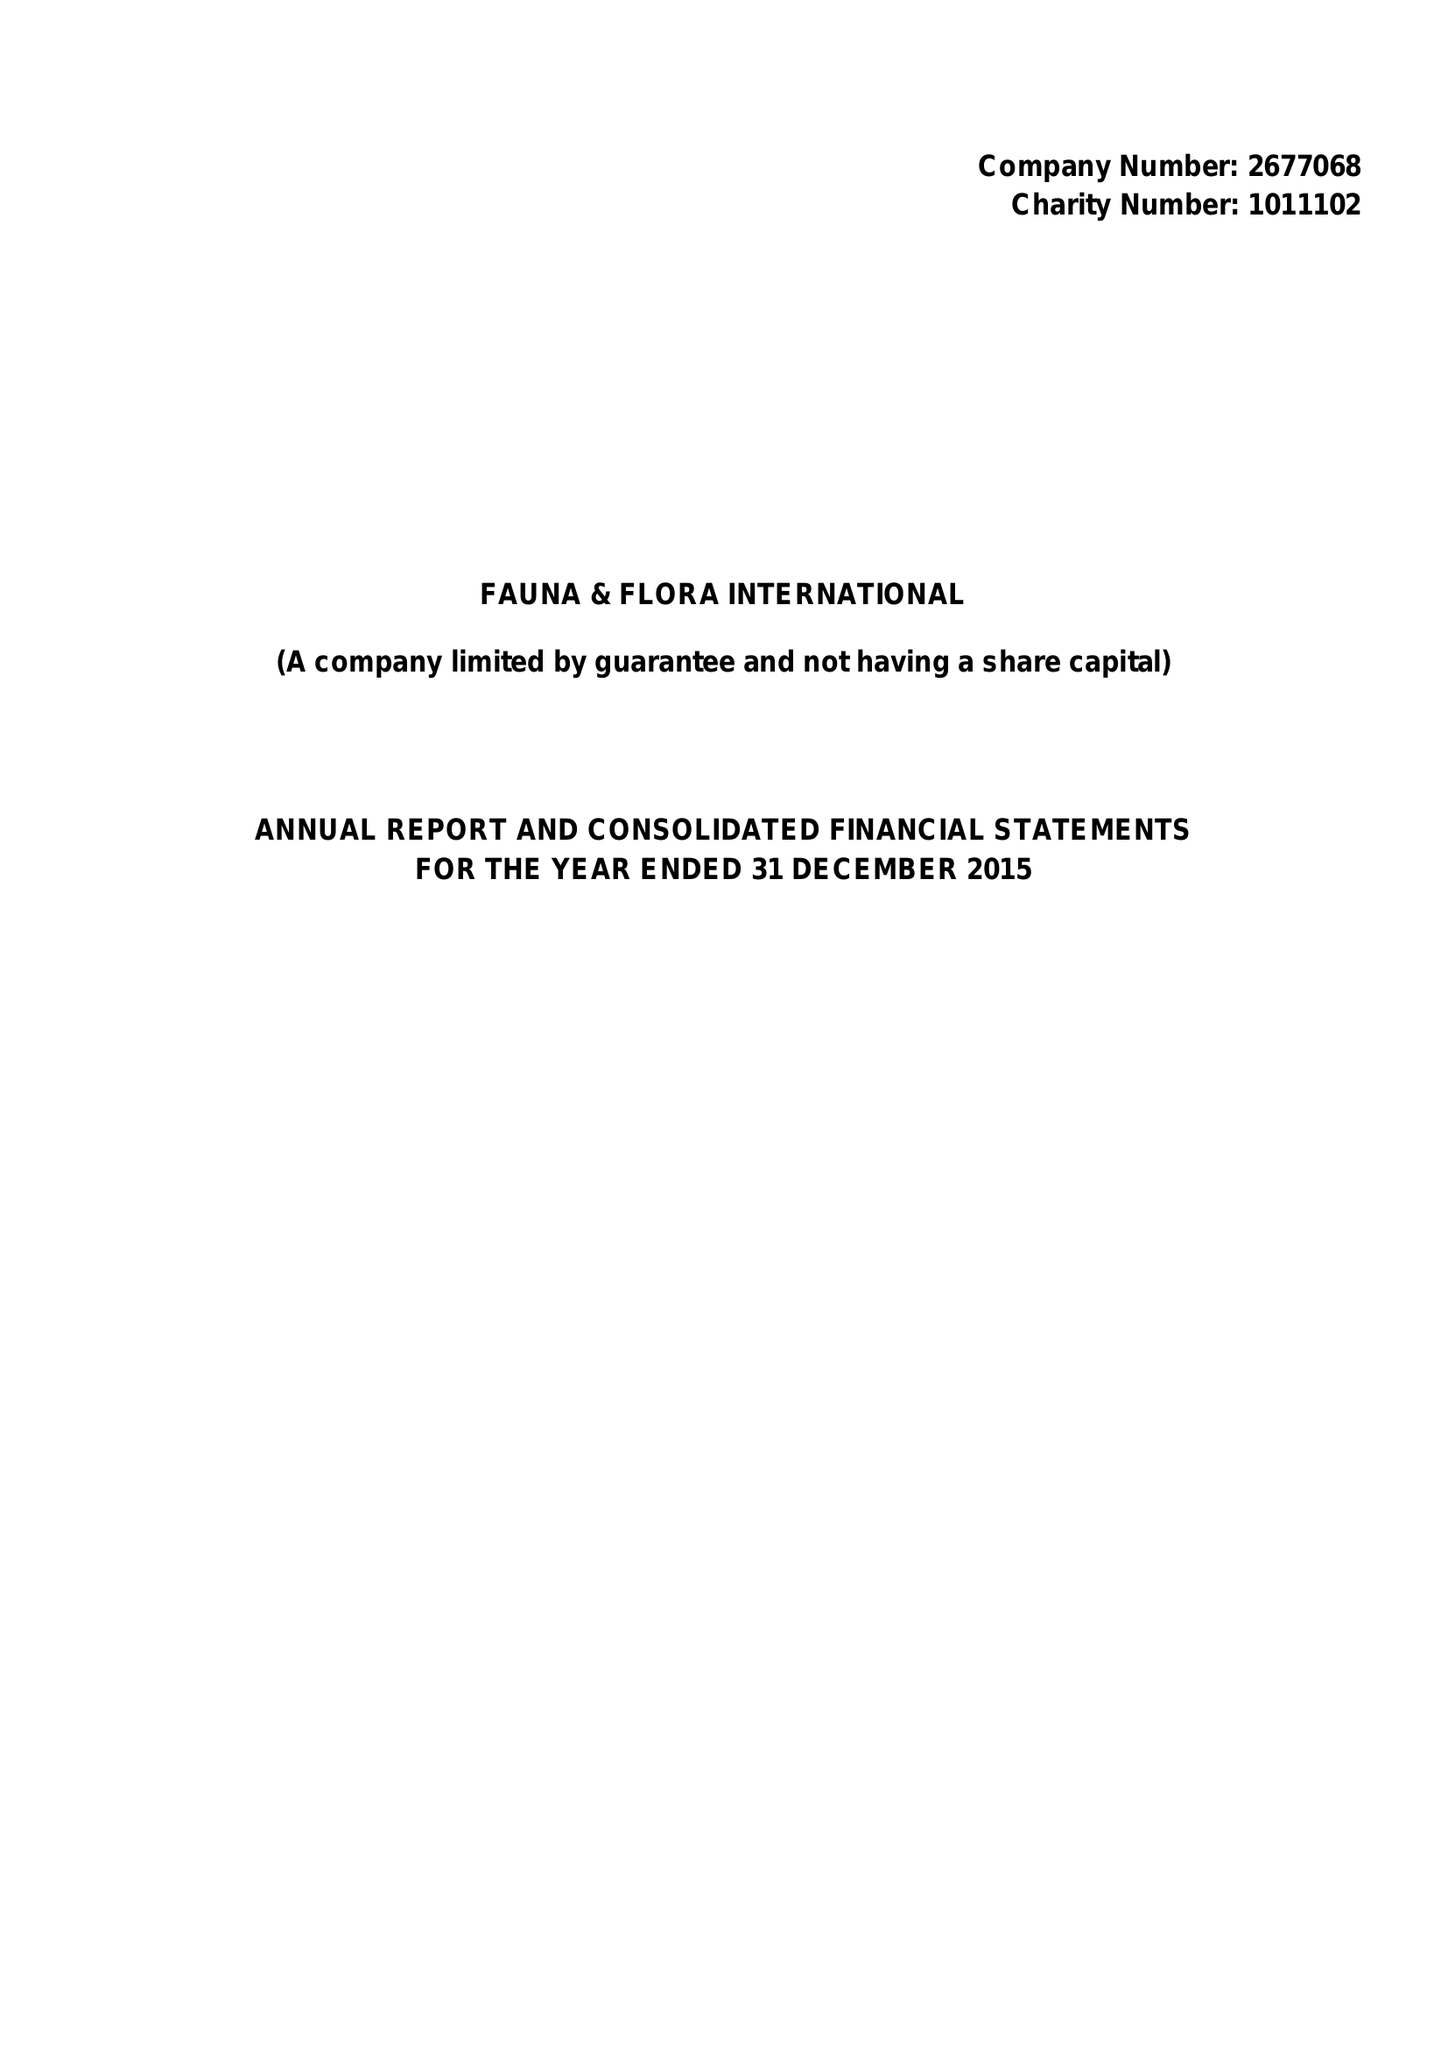What is the value for the charity_number?
Answer the question using a single word or phrase. 1011102 